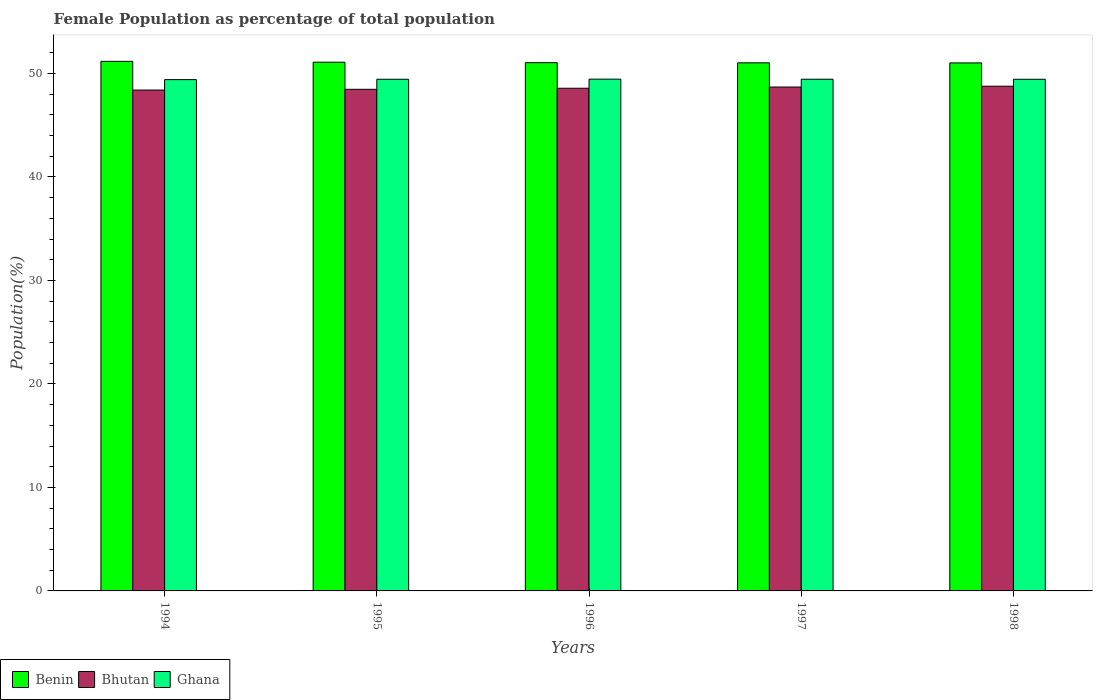How many groups of bars are there?
Offer a terse response. 5. Are the number of bars on each tick of the X-axis equal?
Your response must be concise. Yes. What is the label of the 4th group of bars from the left?
Ensure brevity in your answer.  1997. What is the female population in in Ghana in 1995?
Ensure brevity in your answer.  49.44. Across all years, what is the maximum female population in in Bhutan?
Your answer should be very brief. 48.77. Across all years, what is the minimum female population in in Ghana?
Provide a short and direct response. 49.41. In which year was the female population in in Bhutan maximum?
Your answer should be very brief. 1998. What is the total female population in in Benin in the graph?
Give a very brief answer. 255.35. What is the difference between the female population in in Benin in 1994 and that in 1995?
Your answer should be compact. 0.08. What is the difference between the female population in in Bhutan in 1998 and the female population in in Ghana in 1994?
Your answer should be very brief. -0.64. What is the average female population in in Benin per year?
Provide a short and direct response. 51.07. In the year 1996, what is the difference between the female population in in Bhutan and female population in in Ghana?
Ensure brevity in your answer.  -0.88. What is the ratio of the female population in in Ghana in 1996 to that in 1997?
Provide a short and direct response. 1. Is the female population in in Bhutan in 1996 less than that in 1997?
Offer a very short reply. Yes. What is the difference between the highest and the second highest female population in in Benin?
Offer a terse response. 0.08. What is the difference between the highest and the lowest female population in in Benin?
Offer a terse response. 0.15. What does the 2nd bar from the left in 1996 represents?
Offer a terse response. Bhutan. What does the 2nd bar from the right in 1998 represents?
Offer a very short reply. Bhutan. Is it the case that in every year, the sum of the female population in in Ghana and female population in in Bhutan is greater than the female population in in Benin?
Offer a terse response. Yes. How many years are there in the graph?
Give a very brief answer. 5. What is the difference between two consecutive major ticks on the Y-axis?
Make the answer very short. 10. Are the values on the major ticks of Y-axis written in scientific E-notation?
Provide a short and direct response. No. Does the graph contain grids?
Offer a very short reply. No. How many legend labels are there?
Provide a short and direct response. 3. How are the legend labels stacked?
Provide a succinct answer. Horizontal. What is the title of the graph?
Offer a terse response. Female Population as percentage of total population. Does "Iraq" appear as one of the legend labels in the graph?
Your response must be concise. No. What is the label or title of the Y-axis?
Your answer should be very brief. Population(%). What is the Population(%) of Benin in 1994?
Provide a succinct answer. 51.17. What is the Population(%) in Bhutan in 1994?
Make the answer very short. 48.4. What is the Population(%) in Ghana in 1994?
Provide a succinct answer. 49.41. What is the Population(%) in Benin in 1995?
Your response must be concise. 51.09. What is the Population(%) in Bhutan in 1995?
Make the answer very short. 48.47. What is the Population(%) in Ghana in 1995?
Keep it short and to the point. 49.44. What is the Population(%) in Benin in 1996?
Offer a terse response. 51.05. What is the Population(%) in Bhutan in 1996?
Offer a very short reply. 48.57. What is the Population(%) of Ghana in 1996?
Make the answer very short. 49.45. What is the Population(%) in Benin in 1997?
Your answer should be compact. 51.03. What is the Population(%) in Bhutan in 1997?
Provide a short and direct response. 48.69. What is the Population(%) in Ghana in 1997?
Ensure brevity in your answer.  49.45. What is the Population(%) of Benin in 1998?
Give a very brief answer. 51.02. What is the Population(%) in Bhutan in 1998?
Provide a succinct answer. 48.77. What is the Population(%) of Ghana in 1998?
Ensure brevity in your answer.  49.44. Across all years, what is the maximum Population(%) in Benin?
Keep it short and to the point. 51.17. Across all years, what is the maximum Population(%) of Bhutan?
Provide a succinct answer. 48.77. Across all years, what is the maximum Population(%) of Ghana?
Your answer should be compact. 49.45. Across all years, what is the minimum Population(%) of Benin?
Your answer should be compact. 51.02. Across all years, what is the minimum Population(%) in Bhutan?
Keep it short and to the point. 48.4. Across all years, what is the minimum Population(%) in Ghana?
Provide a short and direct response. 49.41. What is the total Population(%) of Benin in the graph?
Give a very brief answer. 255.35. What is the total Population(%) in Bhutan in the graph?
Offer a terse response. 242.9. What is the total Population(%) of Ghana in the graph?
Keep it short and to the point. 247.18. What is the difference between the Population(%) of Benin in 1994 and that in 1995?
Your answer should be compact. 0.08. What is the difference between the Population(%) of Bhutan in 1994 and that in 1995?
Offer a terse response. -0.07. What is the difference between the Population(%) of Ghana in 1994 and that in 1995?
Make the answer very short. -0.03. What is the difference between the Population(%) of Benin in 1994 and that in 1996?
Provide a short and direct response. 0.13. What is the difference between the Population(%) in Bhutan in 1994 and that in 1996?
Provide a short and direct response. -0.17. What is the difference between the Population(%) of Ghana in 1994 and that in 1996?
Keep it short and to the point. -0.04. What is the difference between the Population(%) in Benin in 1994 and that in 1997?
Keep it short and to the point. 0.14. What is the difference between the Population(%) in Bhutan in 1994 and that in 1997?
Make the answer very short. -0.29. What is the difference between the Population(%) in Ghana in 1994 and that in 1997?
Give a very brief answer. -0.04. What is the difference between the Population(%) in Benin in 1994 and that in 1998?
Your response must be concise. 0.15. What is the difference between the Population(%) in Bhutan in 1994 and that in 1998?
Offer a very short reply. -0.37. What is the difference between the Population(%) of Ghana in 1994 and that in 1998?
Make the answer very short. -0.03. What is the difference between the Population(%) of Benin in 1995 and that in 1996?
Your answer should be compact. 0.04. What is the difference between the Population(%) of Bhutan in 1995 and that in 1996?
Your answer should be very brief. -0.1. What is the difference between the Population(%) in Ghana in 1995 and that in 1996?
Provide a short and direct response. -0.01. What is the difference between the Population(%) in Benin in 1995 and that in 1997?
Your answer should be very brief. 0.06. What is the difference between the Population(%) of Bhutan in 1995 and that in 1997?
Offer a very short reply. -0.22. What is the difference between the Population(%) in Ghana in 1995 and that in 1997?
Offer a very short reply. -0.01. What is the difference between the Population(%) of Benin in 1995 and that in 1998?
Keep it short and to the point. 0.07. What is the difference between the Population(%) of Bhutan in 1995 and that in 1998?
Provide a succinct answer. -0.3. What is the difference between the Population(%) of Ghana in 1995 and that in 1998?
Provide a short and direct response. 0. What is the difference between the Population(%) in Benin in 1996 and that in 1997?
Give a very brief answer. 0.02. What is the difference between the Population(%) of Bhutan in 1996 and that in 1997?
Your answer should be very brief. -0.12. What is the difference between the Population(%) in Ghana in 1996 and that in 1997?
Make the answer very short. 0.01. What is the difference between the Population(%) in Benin in 1996 and that in 1998?
Provide a short and direct response. 0.03. What is the difference between the Population(%) of Bhutan in 1996 and that in 1998?
Provide a short and direct response. -0.2. What is the difference between the Population(%) in Ghana in 1996 and that in 1998?
Offer a very short reply. 0.01. What is the difference between the Population(%) of Benin in 1997 and that in 1998?
Give a very brief answer. 0.01. What is the difference between the Population(%) in Bhutan in 1997 and that in 1998?
Ensure brevity in your answer.  -0.08. What is the difference between the Population(%) of Ghana in 1997 and that in 1998?
Give a very brief answer. 0.01. What is the difference between the Population(%) in Benin in 1994 and the Population(%) in Bhutan in 1995?
Make the answer very short. 2.7. What is the difference between the Population(%) in Benin in 1994 and the Population(%) in Ghana in 1995?
Your answer should be compact. 1.73. What is the difference between the Population(%) of Bhutan in 1994 and the Population(%) of Ghana in 1995?
Provide a succinct answer. -1.04. What is the difference between the Population(%) in Benin in 1994 and the Population(%) in Bhutan in 1996?
Offer a terse response. 2.6. What is the difference between the Population(%) of Benin in 1994 and the Population(%) of Ghana in 1996?
Ensure brevity in your answer.  1.72. What is the difference between the Population(%) of Bhutan in 1994 and the Population(%) of Ghana in 1996?
Ensure brevity in your answer.  -1.05. What is the difference between the Population(%) of Benin in 1994 and the Population(%) of Bhutan in 1997?
Offer a very short reply. 2.48. What is the difference between the Population(%) in Benin in 1994 and the Population(%) in Ghana in 1997?
Offer a terse response. 1.73. What is the difference between the Population(%) of Bhutan in 1994 and the Population(%) of Ghana in 1997?
Make the answer very short. -1.05. What is the difference between the Population(%) of Benin in 1994 and the Population(%) of Bhutan in 1998?
Offer a terse response. 2.4. What is the difference between the Population(%) of Benin in 1994 and the Population(%) of Ghana in 1998?
Provide a succinct answer. 1.73. What is the difference between the Population(%) in Bhutan in 1994 and the Population(%) in Ghana in 1998?
Your answer should be very brief. -1.04. What is the difference between the Population(%) in Benin in 1995 and the Population(%) in Bhutan in 1996?
Your answer should be compact. 2.52. What is the difference between the Population(%) of Benin in 1995 and the Population(%) of Ghana in 1996?
Provide a short and direct response. 1.64. What is the difference between the Population(%) of Bhutan in 1995 and the Population(%) of Ghana in 1996?
Your answer should be very brief. -0.98. What is the difference between the Population(%) in Benin in 1995 and the Population(%) in Bhutan in 1997?
Your answer should be very brief. 2.4. What is the difference between the Population(%) in Benin in 1995 and the Population(%) in Ghana in 1997?
Offer a very short reply. 1.64. What is the difference between the Population(%) in Bhutan in 1995 and the Population(%) in Ghana in 1997?
Keep it short and to the point. -0.98. What is the difference between the Population(%) of Benin in 1995 and the Population(%) of Bhutan in 1998?
Give a very brief answer. 2.32. What is the difference between the Population(%) in Benin in 1995 and the Population(%) in Ghana in 1998?
Keep it short and to the point. 1.65. What is the difference between the Population(%) of Bhutan in 1995 and the Population(%) of Ghana in 1998?
Give a very brief answer. -0.97. What is the difference between the Population(%) of Benin in 1996 and the Population(%) of Bhutan in 1997?
Your answer should be compact. 2.36. What is the difference between the Population(%) of Benin in 1996 and the Population(%) of Ghana in 1997?
Offer a terse response. 1.6. What is the difference between the Population(%) of Bhutan in 1996 and the Population(%) of Ghana in 1997?
Offer a very short reply. -0.87. What is the difference between the Population(%) in Benin in 1996 and the Population(%) in Bhutan in 1998?
Provide a succinct answer. 2.28. What is the difference between the Population(%) in Benin in 1996 and the Population(%) in Ghana in 1998?
Your answer should be very brief. 1.61. What is the difference between the Population(%) of Bhutan in 1996 and the Population(%) of Ghana in 1998?
Your response must be concise. -0.87. What is the difference between the Population(%) of Benin in 1997 and the Population(%) of Bhutan in 1998?
Your response must be concise. 2.26. What is the difference between the Population(%) of Benin in 1997 and the Population(%) of Ghana in 1998?
Make the answer very short. 1.59. What is the difference between the Population(%) in Bhutan in 1997 and the Population(%) in Ghana in 1998?
Provide a succinct answer. -0.75. What is the average Population(%) of Benin per year?
Give a very brief answer. 51.07. What is the average Population(%) in Bhutan per year?
Your answer should be very brief. 48.58. What is the average Population(%) in Ghana per year?
Your answer should be very brief. 49.44. In the year 1994, what is the difference between the Population(%) of Benin and Population(%) of Bhutan?
Ensure brevity in your answer.  2.77. In the year 1994, what is the difference between the Population(%) of Benin and Population(%) of Ghana?
Your answer should be very brief. 1.76. In the year 1994, what is the difference between the Population(%) in Bhutan and Population(%) in Ghana?
Your response must be concise. -1.01. In the year 1995, what is the difference between the Population(%) in Benin and Population(%) in Bhutan?
Your answer should be very brief. 2.62. In the year 1995, what is the difference between the Population(%) of Benin and Population(%) of Ghana?
Keep it short and to the point. 1.65. In the year 1995, what is the difference between the Population(%) of Bhutan and Population(%) of Ghana?
Offer a terse response. -0.97. In the year 1996, what is the difference between the Population(%) in Benin and Population(%) in Bhutan?
Ensure brevity in your answer.  2.47. In the year 1996, what is the difference between the Population(%) of Benin and Population(%) of Ghana?
Provide a short and direct response. 1.59. In the year 1996, what is the difference between the Population(%) in Bhutan and Population(%) in Ghana?
Offer a terse response. -0.88. In the year 1997, what is the difference between the Population(%) of Benin and Population(%) of Bhutan?
Offer a terse response. 2.34. In the year 1997, what is the difference between the Population(%) in Benin and Population(%) in Ghana?
Your answer should be very brief. 1.58. In the year 1997, what is the difference between the Population(%) in Bhutan and Population(%) in Ghana?
Make the answer very short. -0.76. In the year 1998, what is the difference between the Population(%) in Benin and Population(%) in Bhutan?
Your answer should be compact. 2.25. In the year 1998, what is the difference between the Population(%) of Benin and Population(%) of Ghana?
Provide a succinct answer. 1.58. In the year 1998, what is the difference between the Population(%) in Bhutan and Population(%) in Ghana?
Provide a succinct answer. -0.67. What is the ratio of the Population(%) of Benin in 1994 to that in 1995?
Offer a terse response. 1. What is the ratio of the Population(%) of Ghana in 1994 to that in 1996?
Give a very brief answer. 1. What is the ratio of the Population(%) of Bhutan in 1994 to that in 1997?
Give a very brief answer. 0.99. What is the ratio of the Population(%) in Bhutan in 1994 to that in 1998?
Offer a very short reply. 0.99. What is the ratio of the Population(%) in Ghana in 1994 to that in 1998?
Your answer should be very brief. 1. What is the ratio of the Population(%) of Benin in 1995 to that in 1996?
Your answer should be compact. 1. What is the ratio of the Population(%) in Benin in 1995 to that in 1997?
Give a very brief answer. 1. What is the ratio of the Population(%) of Ghana in 1995 to that in 1997?
Make the answer very short. 1. What is the ratio of the Population(%) in Benin in 1995 to that in 1998?
Give a very brief answer. 1. What is the ratio of the Population(%) in Bhutan in 1995 to that in 1998?
Give a very brief answer. 0.99. What is the ratio of the Population(%) in Ghana in 1995 to that in 1998?
Provide a succinct answer. 1. What is the ratio of the Population(%) in Benin in 1996 to that in 1997?
Provide a short and direct response. 1. What is the ratio of the Population(%) in Benin in 1997 to that in 1998?
Offer a very short reply. 1. What is the ratio of the Population(%) in Bhutan in 1997 to that in 1998?
Give a very brief answer. 1. What is the ratio of the Population(%) of Ghana in 1997 to that in 1998?
Your response must be concise. 1. What is the difference between the highest and the second highest Population(%) of Benin?
Make the answer very short. 0.08. What is the difference between the highest and the second highest Population(%) of Bhutan?
Make the answer very short. 0.08. What is the difference between the highest and the second highest Population(%) of Ghana?
Offer a very short reply. 0.01. What is the difference between the highest and the lowest Population(%) of Benin?
Give a very brief answer. 0.15. What is the difference between the highest and the lowest Population(%) of Bhutan?
Offer a terse response. 0.37. What is the difference between the highest and the lowest Population(%) of Ghana?
Provide a short and direct response. 0.04. 